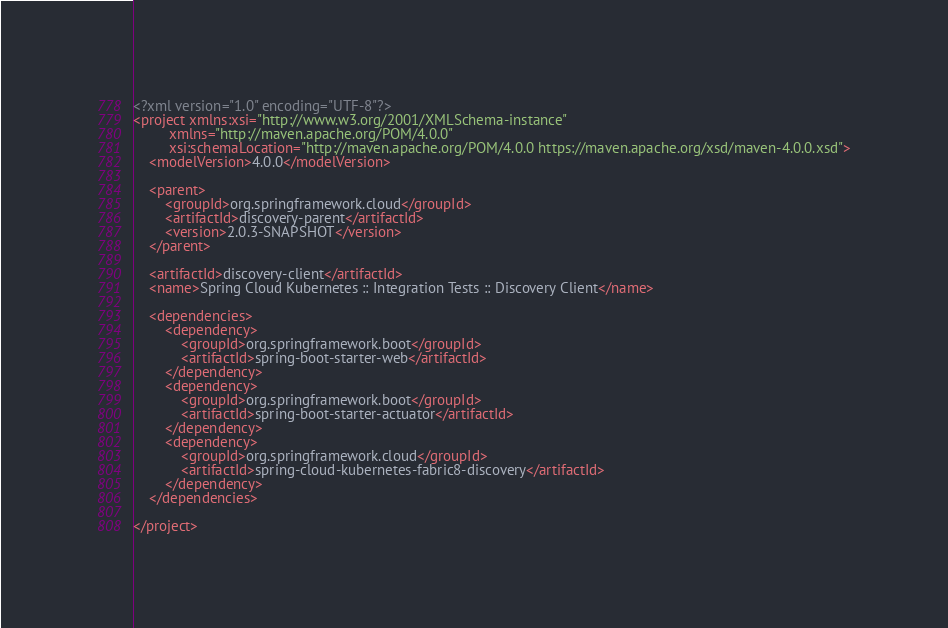Convert code to text. <code><loc_0><loc_0><loc_500><loc_500><_XML_><?xml version="1.0" encoding="UTF-8"?>
<project xmlns:xsi="http://www.w3.org/2001/XMLSchema-instance"
		 xmlns="http://maven.apache.org/POM/4.0.0"
		 xsi:schemaLocation="http://maven.apache.org/POM/4.0.0 https://maven.apache.org/xsd/maven-4.0.0.xsd">
	<modelVersion>4.0.0</modelVersion>

	<parent>
		<groupId>org.springframework.cloud</groupId>
		<artifactId>discovery-parent</artifactId>
		<version>2.0.3-SNAPSHOT</version>
	</parent>

	<artifactId>discovery-client</artifactId>
	<name>Spring Cloud Kubernetes :: Integration Tests :: Discovery Client</name>

	<dependencies>
		<dependency>
			<groupId>org.springframework.boot</groupId>
			<artifactId>spring-boot-starter-web</artifactId>
		</dependency>
		<dependency>
			<groupId>org.springframework.boot</groupId>
			<artifactId>spring-boot-starter-actuator</artifactId>
		</dependency>
		<dependency>
			<groupId>org.springframework.cloud</groupId>
			<artifactId>spring-cloud-kubernetes-fabric8-discovery</artifactId>
		</dependency>
	</dependencies>

</project>
</code> 